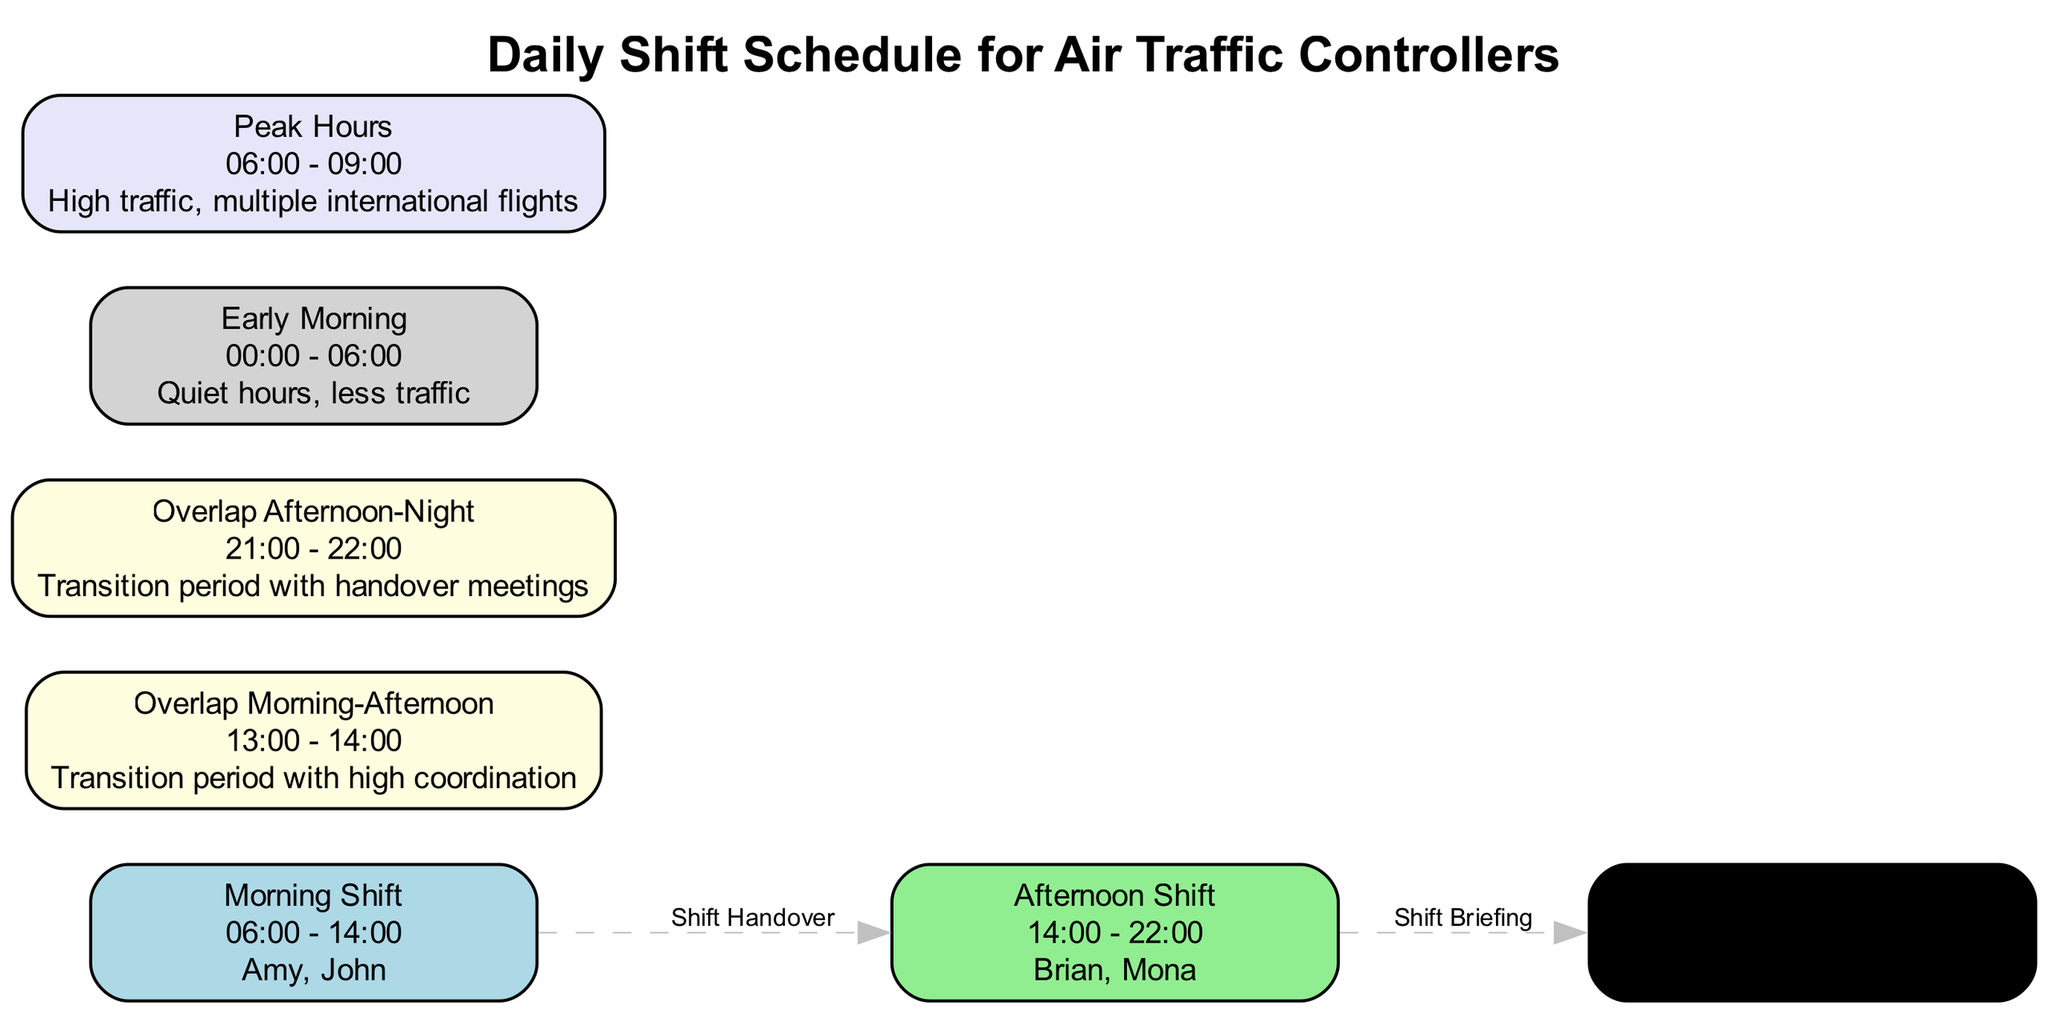What are the controllers in the Night Shift? The Night Shift node lists the controllers as Nina and Steve. By looking at the node properties in the diagram, we can directly identify the names associated with this shift.
Answer: Nina, Steve What time range does the Afternoon Shift cover? The Afternoon Shift node specifies its time range as 14:00 - 22:00. This information is clearly stated within the label of the node.
Answer: 14:00 - 22:00 How many shifts are there in total? There are four shifts represented in the diagram: Morning Shift, Afternoon Shift, Night Shift, and two overlap periods (Morning-Afternoon and Afternoon-Night). Counting each node gives us the total.
Answer: 6 What is the color representing the Early Morning? The Early Morning node is shaded light gray according to its properties in the diagram. Each node has a specific color assigned which can be seen visually.
Answer: lightgray What happens during the Overlap Morning-Afternoon period? The description for the Overlap Morning-Afternoon period mentions it is a transition period with high coordination. This is noted in the node's description, outlining its function.
Answer: Transition period with high coordination Which two controllers are involved in the Afternoon Shift handover? The edge connecting Morning Shift to Afternoon Shift indicates that the morning controllers (Amy and John) debrief the afternoon team (Brian and Mona). This handover relationship is defined in the diagram edges.
Answer: Amy, John What is indicated during Peak Hours? The Peak Hours node indicates high traffic with multiple international flights occurring from 06:00 to 09:00. The description provides context for this time period and its significance.
Answer: High traffic, multiple international flights What is the overlap between the Afternoon and Night shifts? The overlap between the Afternoon and Night shifts is labeled as "Overlap Afternoon-Night" during the time range of 21:00 - 22:00, and features a description regarding handover meetings. This information can be directly found in the overlap node.
Answer: Handover meetings 